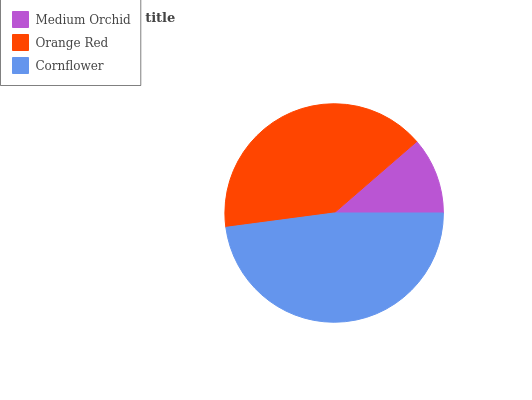Is Medium Orchid the minimum?
Answer yes or no. Yes. Is Cornflower the maximum?
Answer yes or no. Yes. Is Orange Red the minimum?
Answer yes or no. No. Is Orange Red the maximum?
Answer yes or no. No. Is Orange Red greater than Medium Orchid?
Answer yes or no. Yes. Is Medium Orchid less than Orange Red?
Answer yes or no. Yes. Is Medium Orchid greater than Orange Red?
Answer yes or no. No. Is Orange Red less than Medium Orchid?
Answer yes or no. No. Is Orange Red the high median?
Answer yes or no. Yes. Is Orange Red the low median?
Answer yes or no. Yes. Is Medium Orchid the high median?
Answer yes or no. No. Is Medium Orchid the low median?
Answer yes or no. No. 